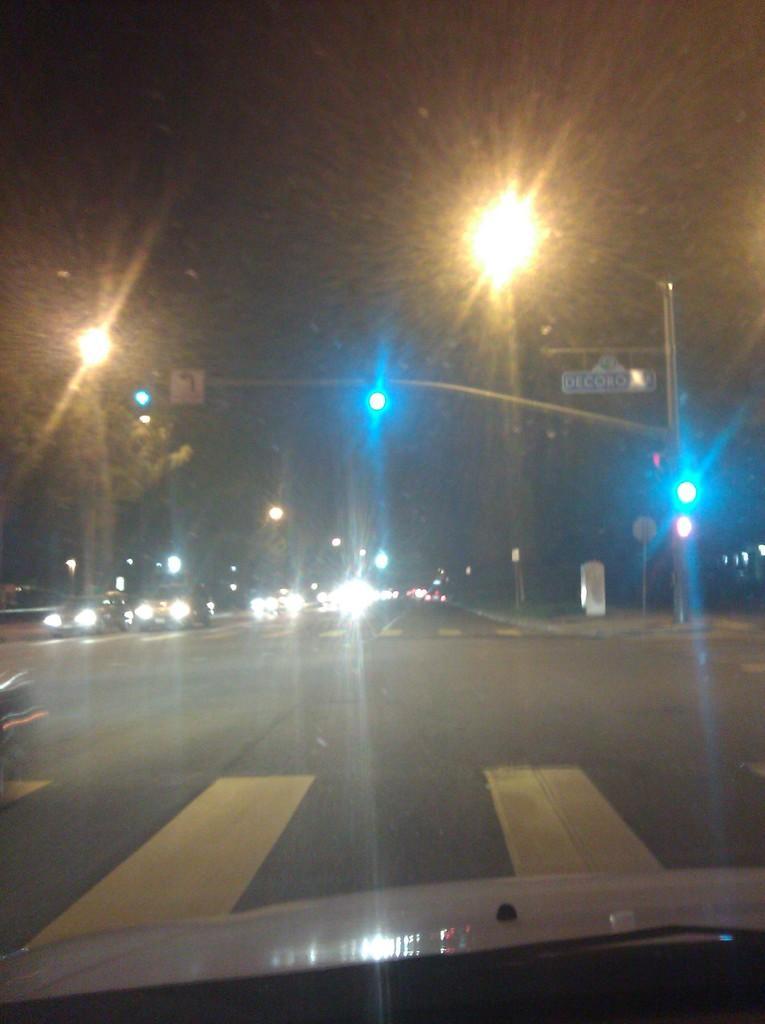Can you describe this image briefly? Here we can see a vehicle front glass. Through this glass we can see the vehicles on the road,street lights,poles and on the right side there is a small board attached to a pole. 